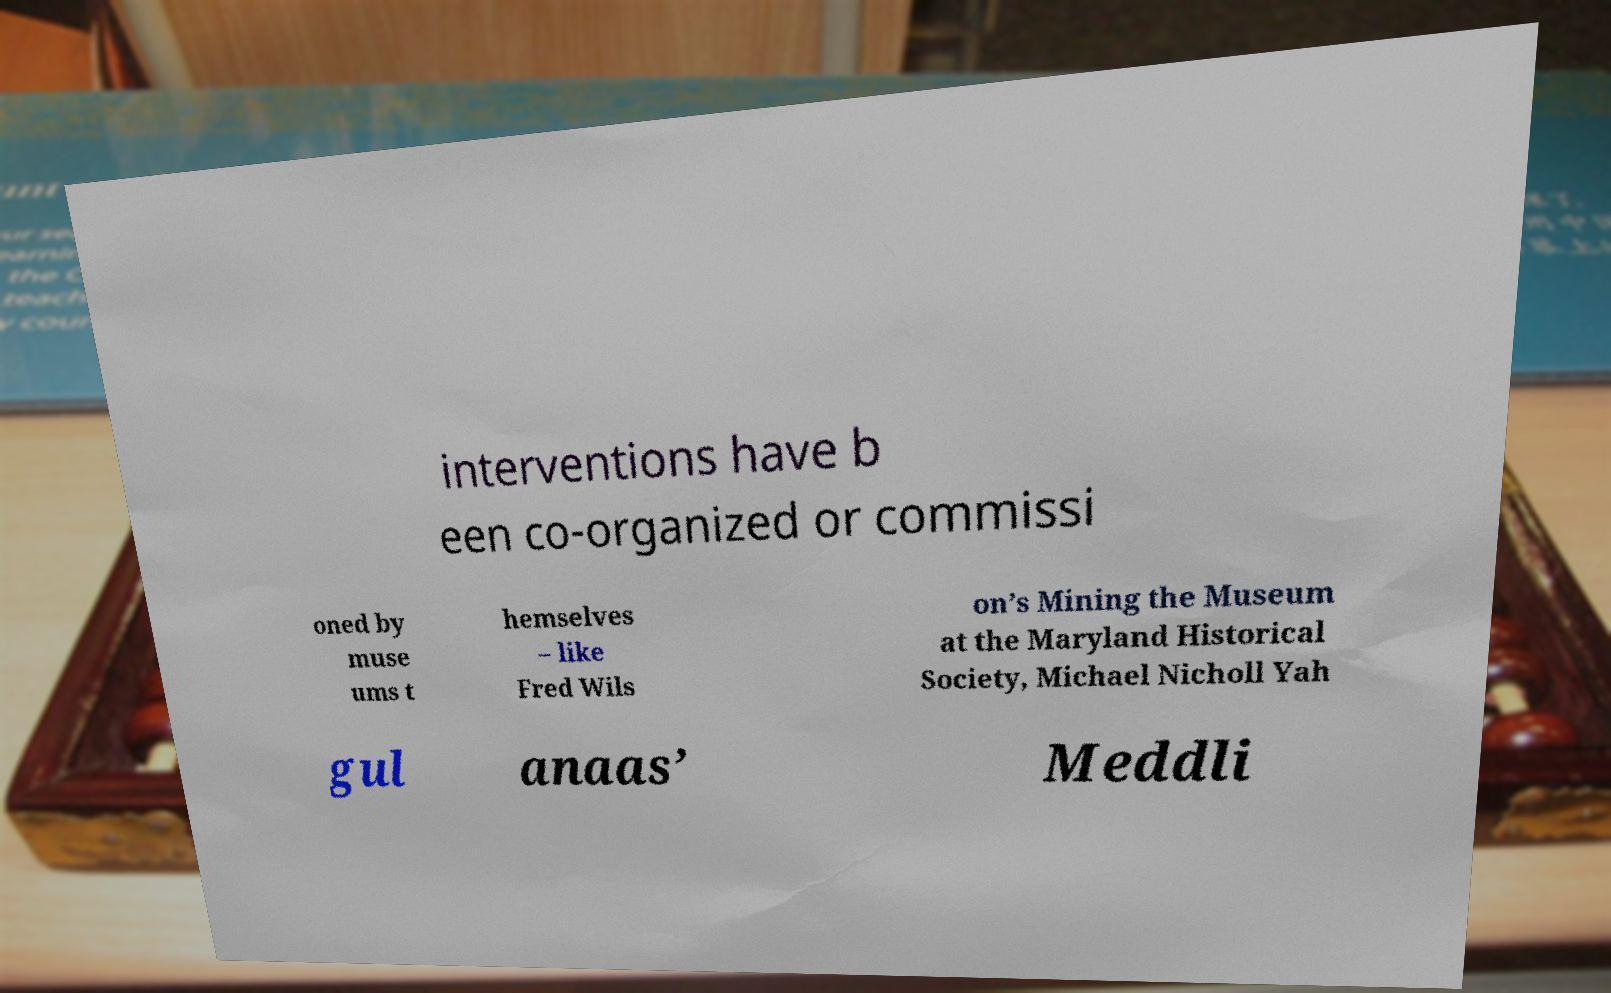For documentation purposes, I need the text within this image transcribed. Could you provide that? interventions have b een co-organized or commissi oned by muse ums t hemselves – like Fred Wils on’s Mining the Museum at the Maryland Historical Society, Michael Nicholl Yah gul anaas’ Meddli 